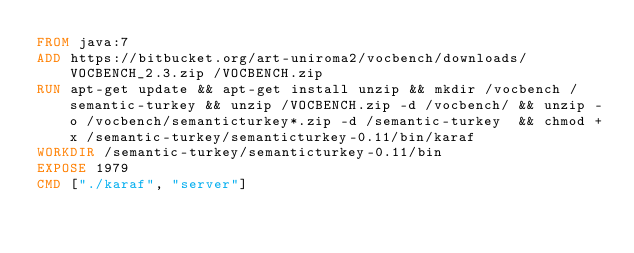Convert code to text. <code><loc_0><loc_0><loc_500><loc_500><_Dockerfile_>FROM java:7
ADD https://bitbucket.org/art-uniroma2/vocbench/downloads/VOCBENCH_2.3.zip /VOCBENCH.zip
RUN apt-get update && apt-get install unzip && mkdir /vocbench /semantic-turkey && unzip /VOCBENCH.zip -d /vocbench/ && unzip -o /vocbench/semanticturkey*.zip -d /semantic-turkey  && chmod +x /semantic-turkey/semanticturkey-0.11/bin/karaf
WORKDIR /semantic-turkey/semanticturkey-0.11/bin
EXPOSE 1979
CMD ["./karaf", "server"]</code> 